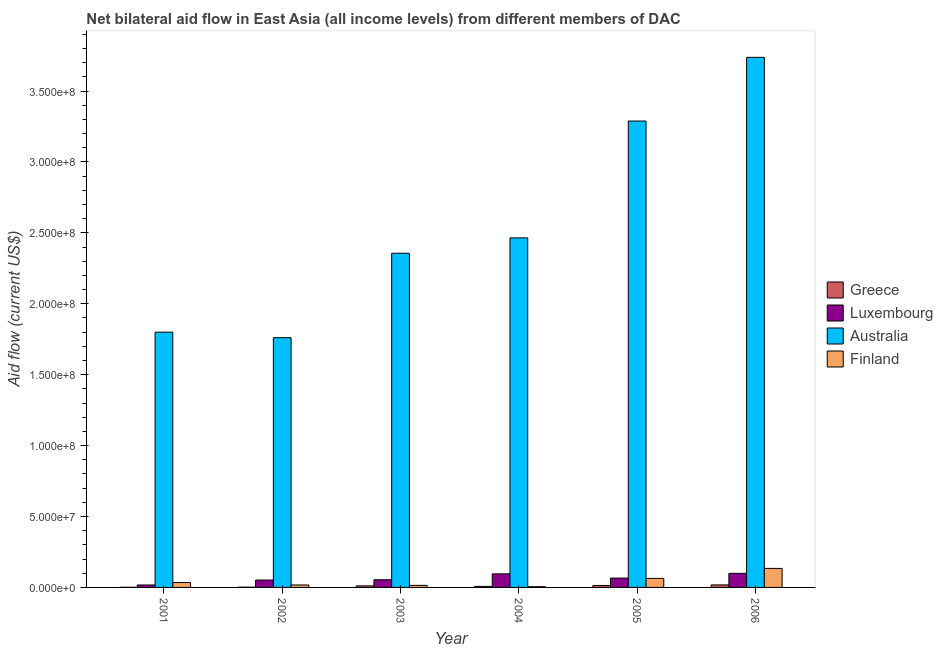How many different coloured bars are there?
Your response must be concise. 4. How many groups of bars are there?
Make the answer very short. 6. Are the number of bars per tick equal to the number of legend labels?
Give a very brief answer. Yes. Are the number of bars on each tick of the X-axis equal?
Keep it short and to the point. Yes. What is the label of the 2nd group of bars from the left?
Your answer should be very brief. 2002. In how many cases, is the number of bars for a given year not equal to the number of legend labels?
Your answer should be very brief. 0. What is the amount of aid given by finland in 2004?
Your answer should be very brief. 5.30e+05. Across all years, what is the maximum amount of aid given by australia?
Offer a terse response. 3.74e+08. Across all years, what is the minimum amount of aid given by greece?
Your answer should be compact. 1.10e+05. What is the total amount of aid given by australia in the graph?
Make the answer very short. 1.54e+09. What is the difference between the amount of aid given by luxembourg in 2001 and that in 2004?
Ensure brevity in your answer.  -7.84e+06. What is the difference between the amount of aid given by greece in 2001 and the amount of aid given by finland in 2002?
Ensure brevity in your answer.  -9.00e+04. What is the average amount of aid given by finland per year?
Give a very brief answer. 4.49e+06. In the year 2005, what is the difference between the amount of aid given by luxembourg and amount of aid given by finland?
Provide a short and direct response. 0. What is the ratio of the amount of aid given by greece in 2001 to that in 2004?
Your answer should be compact. 0.15. Is the amount of aid given by greece in 2004 less than that in 2006?
Your answer should be compact. Yes. Is the difference between the amount of aid given by australia in 2005 and 2006 greater than the difference between the amount of aid given by luxembourg in 2005 and 2006?
Offer a terse response. No. What is the difference between the highest and the lowest amount of aid given by luxembourg?
Offer a terse response. 8.19e+06. Is it the case that in every year, the sum of the amount of aid given by greece and amount of aid given by australia is greater than the sum of amount of aid given by finland and amount of aid given by luxembourg?
Give a very brief answer. No. What does the 4th bar from the left in 2001 represents?
Provide a succinct answer. Finland. Are all the bars in the graph horizontal?
Ensure brevity in your answer.  No. What is the difference between two consecutive major ticks on the Y-axis?
Ensure brevity in your answer.  5.00e+07. Does the graph contain any zero values?
Give a very brief answer. No. Where does the legend appear in the graph?
Your answer should be very brief. Center right. How are the legend labels stacked?
Keep it short and to the point. Vertical. What is the title of the graph?
Provide a short and direct response. Net bilateral aid flow in East Asia (all income levels) from different members of DAC. What is the Aid flow (current US$) in Greece in 2001?
Your answer should be very brief. 1.10e+05. What is the Aid flow (current US$) of Luxembourg in 2001?
Make the answer very short. 1.73e+06. What is the Aid flow (current US$) in Australia in 2001?
Keep it short and to the point. 1.80e+08. What is the Aid flow (current US$) of Finland in 2001?
Offer a very short reply. 3.45e+06. What is the Aid flow (current US$) in Luxembourg in 2002?
Ensure brevity in your answer.  5.21e+06. What is the Aid flow (current US$) of Australia in 2002?
Offer a terse response. 1.76e+08. What is the Aid flow (current US$) in Finland in 2002?
Your response must be concise. 1.73e+06. What is the Aid flow (current US$) of Greece in 2003?
Offer a terse response. 1.09e+06. What is the Aid flow (current US$) of Luxembourg in 2003?
Your answer should be very brief. 5.42e+06. What is the Aid flow (current US$) in Australia in 2003?
Your response must be concise. 2.36e+08. What is the Aid flow (current US$) of Finland in 2003?
Offer a terse response. 1.45e+06. What is the Aid flow (current US$) in Greece in 2004?
Give a very brief answer. 7.20e+05. What is the Aid flow (current US$) in Luxembourg in 2004?
Make the answer very short. 9.57e+06. What is the Aid flow (current US$) of Australia in 2004?
Give a very brief answer. 2.46e+08. What is the Aid flow (current US$) in Finland in 2004?
Provide a succinct answer. 5.30e+05. What is the Aid flow (current US$) in Greece in 2005?
Offer a terse response. 1.38e+06. What is the Aid flow (current US$) of Luxembourg in 2005?
Keep it short and to the point. 6.58e+06. What is the Aid flow (current US$) of Australia in 2005?
Provide a short and direct response. 3.29e+08. What is the Aid flow (current US$) of Finland in 2005?
Ensure brevity in your answer.  6.36e+06. What is the Aid flow (current US$) of Greece in 2006?
Give a very brief answer. 1.77e+06. What is the Aid flow (current US$) in Luxembourg in 2006?
Ensure brevity in your answer.  9.92e+06. What is the Aid flow (current US$) in Australia in 2006?
Keep it short and to the point. 3.74e+08. What is the Aid flow (current US$) in Finland in 2006?
Provide a succinct answer. 1.34e+07. Across all years, what is the maximum Aid flow (current US$) in Greece?
Keep it short and to the point. 1.77e+06. Across all years, what is the maximum Aid flow (current US$) in Luxembourg?
Ensure brevity in your answer.  9.92e+06. Across all years, what is the maximum Aid flow (current US$) in Australia?
Offer a terse response. 3.74e+08. Across all years, what is the maximum Aid flow (current US$) of Finland?
Provide a succinct answer. 1.34e+07. Across all years, what is the minimum Aid flow (current US$) of Greece?
Your answer should be very brief. 1.10e+05. Across all years, what is the minimum Aid flow (current US$) in Luxembourg?
Your response must be concise. 1.73e+06. Across all years, what is the minimum Aid flow (current US$) in Australia?
Give a very brief answer. 1.76e+08. Across all years, what is the minimum Aid flow (current US$) in Finland?
Keep it short and to the point. 5.30e+05. What is the total Aid flow (current US$) in Greece in the graph?
Offer a terse response. 5.27e+06. What is the total Aid flow (current US$) of Luxembourg in the graph?
Make the answer very short. 3.84e+07. What is the total Aid flow (current US$) in Australia in the graph?
Provide a succinct answer. 1.54e+09. What is the total Aid flow (current US$) in Finland in the graph?
Ensure brevity in your answer.  2.69e+07. What is the difference between the Aid flow (current US$) of Greece in 2001 and that in 2002?
Offer a terse response. -9.00e+04. What is the difference between the Aid flow (current US$) in Luxembourg in 2001 and that in 2002?
Keep it short and to the point. -3.48e+06. What is the difference between the Aid flow (current US$) of Australia in 2001 and that in 2002?
Provide a short and direct response. 3.90e+06. What is the difference between the Aid flow (current US$) of Finland in 2001 and that in 2002?
Offer a terse response. 1.72e+06. What is the difference between the Aid flow (current US$) in Greece in 2001 and that in 2003?
Provide a short and direct response. -9.80e+05. What is the difference between the Aid flow (current US$) in Luxembourg in 2001 and that in 2003?
Provide a succinct answer. -3.69e+06. What is the difference between the Aid flow (current US$) in Australia in 2001 and that in 2003?
Your answer should be very brief. -5.56e+07. What is the difference between the Aid flow (current US$) of Greece in 2001 and that in 2004?
Make the answer very short. -6.10e+05. What is the difference between the Aid flow (current US$) in Luxembourg in 2001 and that in 2004?
Your response must be concise. -7.84e+06. What is the difference between the Aid flow (current US$) of Australia in 2001 and that in 2004?
Provide a short and direct response. -6.65e+07. What is the difference between the Aid flow (current US$) of Finland in 2001 and that in 2004?
Give a very brief answer. 2.92e+06. What is the difference between the Aid flow (current US$) of Greece in 2001 and that in 2005?
Your response must be concise. -1.27e+06. What is the difference between the Aid flow (current US$) of Luxembourg in 2001 and that in 2005?
Your answer should be compact. -4.85e+06. What is the difference between the Aid flow (current US$) of Australia in 2001 and that in 2005?
Offer a terse response. -1.49e+08. What is the difference between the Aid flow (current US$) of Finland in 2001 and that in 2005?
Your answer should be compact. -2.91e+06. What is the difference between the Aid flow (current US$) of Greece in 2001 and that in 2006?
Keep it short and to the point. -1.66e+06. What is the difference between the Aid flow (current US$) in Luxembourg in 2001 and that in 2006?
Your answer should be very brief. -8.19e+06. What is the difference between the Aid flow (current US$) of Australia in 2001 and that in 2006?
Your answer should be very brief. -1.94e+08. What is the difference between the Aid flow (current US$) of Finland in 2001 and that in 2006?
Your answer should be very brief. -9.95e+06. What is the difference between the Aid flow (current US$) of Greece in 2002 and that in 2003?
Your answer should be compact. -8.90e+05. What is the difference between the Aid flow (current US$) of Luxembourg in 2002 and that in 2003?
Make the answer very short. -2.10e+05. What is the difference between the Aid flow (current US$) of Australia in 2002 and that in 2003?
Your answer should be very brief. -5.95e+07. What is the difference between the Aid flow (current US$) in Greece in 2002 and that in 2004?
Offer a terse response. -5.20e+05. What is the difference between the Aid flow (current US$) in Luxembourg in 2002 and that in 2004?
Ensure brevity in your answer.  -4.36e+06. What is the difference between the Aid flow (current US$) in Australia in 2002 and that in 2004?
Make the answer very short. -7.04e+07. What is the difference between the Aid flow (current US$) of Finland in 2002 and that in 2004?
Your response must be concise. 1.20e+06. What is the difference between the Aid flow (current US$) of Greece in 2002 and that in 2005?
Keep it short and to the point. -1.18e+06. What is the difference between the Aid flow (current US$) in Luxembourg in 2002 and that in 2005?
Your answer should be compact. -1.37e+06. What is the difference between the Aid flow (current US$) in Australia in 2002 and that in 2005?
Keep it short and to the point. -1.53e+08. What is the difference between the Aid flow (current US$) in Finland in 2002 and that in 2005?
Offer a very short reply. -4.63e+06. What is the difference between the Aid flow (current US$) of Greece in 2002 and that in 2006?
Provide a succinct answer. -1.57e+06. What is the difference between the Aid flow (current US$) of Luxembourg in 2002 and that in 2006?
Your answer should be compact. -4.71e+06. What is the difference between the Aid flow (current US$) of Australia in 2002 and that in 2006?
Offer a terse response. -1.98e+08. What is the difference between the Aid flow (current US$) in Finland in 2002 and that in 2006?
Provide a short and direct response. -1.17e+07. What is the difference between the Aid flow (current US$) of Greece in 2003 and that in 2004?
Offer a very short reply. 3.70e+05. What is the difference between the Aid flow (current US$) of Luxembourg in 2003 and that in 2004?
Offer a very short reply. -4.15e+06. What is the difference between the Aid flow (current US$) of Australia in 2003 and that in 2004?
Your answer should be compact. -1.08e+07. What is the difference between the Aid flow (current US$) in Finland in 2003 and that in 2004?
Your answer should be very brief. 9.20e+05. What is the difference between the Aid flow (current US$) of Greece in 2003 and that in 2005?
Keep it short and to the point. -2.90e+05. What is the difference between the Aid flow (current US$) in Luxembourg in 2003 and that in 2005?
Offer a terse response. -1.16e+06. What is the difference between the Aid flow (current US$) in Australia in 2003 and that in 2005?
Your answer should be very brief. -9.32e+07. What is the difference between the Aid flow (current US$) of Finland in 2003 and that in 2005?
Your answer should be very brief. -4.91e+06. What is the difference between the Aid flow (current US$) of Greece in 2003 and that in 2006?
Provide a short and direct response. -6.80e+05. What is the difference between the Aid flow (current US$) in Luxembourg in 2003 and that in 2006?
Provide a succinct answer. -4.50e+06. What is the difference between the Aid flow (current US$) of Australia in 2003 and that in 2006?
Offer a terse response. -1.38e+08. What is the difference between the Aid flow (current US$) in Finland in 2003 and that in 2006?
Your answer should be compact. -1.20e+07. What is the difference between the Aid flow (current US$) in Greece in 2004 and that in 2005?
Provide a short and direct response. -6.60e+05. What is the difference between the Aid flow (current US$) in Luxembourg in 2004 and that in 2005?
Your answer should be very brief. 2.99e+06. What is the difference between the Aid flow (current US$) in Australia in 2004 and that in 2005?
Keep it short and to the point. -8.24e+07. What is the difference between the Aid flow (current US$) in Finland in 2004 and that in 2005?
Make the answer very short. -5.83e+06. What is the difference between the Aid flow (current US$) of Greece in 2004 and that in 2006?
Keep it short and to the point. -1.05e+06. What is the difference between the Aid flow (current US$) of Luxembourg in 2004 and that in 2006?
Your answer should be very brief. -3.50e+05. What is the difference between the Aid flow (current US$) of Australia in 2004 and that in 2006?
Your response must be concise. -1.27e+08. What is the difference between the Aid flow (current US$) of Finland in 2004 and that in 2006?
Offer a terse response. -1.29e+07. What is the difference between the Aid flow (current US$) in Greece in 2005 and that in 2006?
Your answer should be very brief. -3.90e+05. What is the difference between the Aid flow (current US$) of Luxembourg in 2005 and that in 2006?
Give a very brief answer. -3.34e+06. What is the difference between the Aid flow (current US$) in Australia in 2005 and that in 2006?
Keep it short and to the point. -4.49e+07. What is the difference between the Aid flow (current US$) of Finland in 2005 and that in 2006?
Your answer should be compact. -7.04e+06. What is the difference between the Aid flow (current US$) in Greece in 2001 and the Aid flow (current US$) in Luxembourg in 2002?
Keep it short and to the point. -5.10e+06. What is the difference between the Aid flow (current US$) of Greece in 2001 and the Aid flow (current US$) of Australia in 2002?
Your response must be concise. -1.76e+08. What is the difference between the Aid flow (current US$) in Greece in 2001 and the Aid flow (current US$) in Finland in 2002?
Your answer should be very brief. -1.62e+06. What is the difference between the Aid flow (current US$) in Luxembourg in 2001 and the Aid flow (current US$) in Australia in 2002?
Give a very brief answer. -1.74e+08. What is the difference between the Aid flow (current US$) of Australia in 2001 and the Aid flow (current US$) of Finland in 2002?
Offer a very short reply. 1.78e+08. What is the difference between the Aid flow (current US$) in Greece in 2001 and the Aid flow (current US$) in Luxembourg in 2003?
Your answer should be compact. -5.31e+06. What is the difference between the Aid flow (current US$) in Greece in 2001 and the Aid flow (current US$) in Australia in 2003?
Provide a short and direct response. -2.36e+08. What is the difference between the Aid flow (current US$) in Greece in 2001 and the Aid flow (current US$) in Finland in 2003?
Offer a terse response. -1.34e+06. What is the difference between the Aid flow (current US$) of Luxembourg in 2001 and the Aid flow (current US$) of Australia in 2003?
Ensure brevity in your answer.  -2.34e+08. What is the difference between the Aid flow (current US$) in Australia in 2001 and the Aid flow (current US$) in Finland in 2003?
Keep it short and to the point. 1.79e+08. What is the difference between the Aid flow (current US$) of Greece in 2001 and the Aid flow (current US$) of Luxembourg in 2004?
Ensure brevity in your answer.  -9.46e+06. What is the difference between the Aid flow (current US$) in Greece in 2001 and the Aid flow (current US$) in Australia in 2004?
Ensure brevity in your answer.  -2.46e+08. What is the difference between the Aid flow (current US$) of Greece in 2001 and the Aid flow (current US$) of Finland in 2004?
Your answer should be very brief. -4.20e+05. What is the difference between the Aid flow (current US$) of Luxembourg in 2001 and the Aid flow (current US$) of Australia in 2004?
Your answer should be compact. -2.45e+08. What is the difference between the Aid flow (current US$) in Luxembourg in 2001 and the Aid flow (current US$) in Finland in 2004?
Your response must be concise. 1.20e+06. What is the difference between the Aid flow (current US$) of Australia in 2001 and the Aid flow (current US$) of Finland in 2004?
Ensure brevity in your answer.  1.79e+08. What is the difference between the Aid flow (current US$) in Greece in 2001 and the Aid flow (current US$) in Luxembourg in 2005?
Your response must be concise. -6.47e+06. What is the difference between the Aid flow (current US$) in Greece in 2001 and the Aid flow (current US$) in Australia in 2005?
Give a very brief answer. -3.29e+08. What is the difference between the Aid flow (current US$) in Greece in 2001 and the Aid flow (current US$) in Finland in 2005?
Offer a very short reply. -6.25e+06. What is the difference between the Aid flow (current US$) of Luxembourg in 2001 and the Aid flow (current US$) of Australia in 2005?
Offer a very short reply. -3.27e+08. What is the difference between the Aid flow (current US$) of Luxembourg in 2001 and the Aid flow (current US$) of Finland in 2005?
Give a very brief answer. -4.63e+06. What is the difference between the Aid flow (current US$) of Australia in 2001 and the Aid flow (current US$) of Finland in 2005?
Provide a short and direct response. 1.74e+08. What is the difference between the Aid flow (current US$) of Greece in 2001 and the Aid flow (current US$) of Luxembourg in 2006?
Make the answer very short. -9.81e+06. What is the difference between the Aid flow (current US$) in Greece in 2001 and the Aid flow (current US$) in Australia in 2006?
Your answer should be very brief. -3.74e+08. What is the difference between the Aid flow (current US$) of Greece in 2001 and the Aid flow (current US$) of Finland in 2006?
Keep it short and to the point. -1.33e+07. What is the difference between the Aid flow (current US$) in Luxembourg in 2001 and the Aid flow (current US$) in Australia in 2006?
Offer a very short reply. -3.72e+08. What is the difference between the Aid flow (current US$) in Luxembourg in 2001 and the Aid flow (current US$) in Finland in 2006?
Give a very brief answer. -1.17e+07. What is the difference between the Aid flow (current US$) of Australia in 2001 and the Aid flow (current US$) of Finland in 2006?
Your answer should be compact. 1.67e+08. What is the difference between the Aid flow (current US$) in Greece in 2002 and the Aid flow (current US$) in Luxembourg in 2003?
Keep it short and to the point. -5.22e+06. What is the difference between the Aid flow (current US$) in Greece in 2002 and the Aid flow (current US$) in Australia in 2003?
Your answer should be very brief. -2.35e+08. What is the difference between the Aid flow (current US$) of Greece in 2002 and the Aid flow (current US$) of Finland in 2003?
Your answer should be very brief. -1.25e+06. What is the difference between the Aid flow (current US$) of Luxembourg in 2002 and the Aid flow (current US$) of Australia in 2003?
Provide a short and direct response. -2.30e+08. What is the difference between the Aid flow (current US$) in Luxembourg in 2002 and the Aid flow (current US$) in Finland in 2003?
Offer a terse response. 3.76e+06. What is the difference between the Aid flow (current US$) of Australia in 2002 and the Aid flow (current US$) of Finland in 2003?
Your answer should be compact. 1.75e+08. What is the difference between the Aid flow (current US$) in Greece in 2002 and the Aid flow (current US$) in Luxembourg in 2004?
Keep it short and to the point. -9.37e+06. What is the difference between the Aid flow (current US$) of Greece in 2002 and the Aid flow (current US$) of Australia in 2004?
Your answer should be very brief. -2.46e+08. What is the difference between the Aid flow (current US$) of Greece in 2002 and the Aid flow (current US$) of Finland in 2004?
Keep it short and to the point. -3.30e+05. What is the difference between the Aid flow (current US$) in Luxembourg in 2002 and the Aid flow (current US$) in Australia in 2004?
Make the answer very short. -2.41e+08. What is the difference between the Aid flow (current US$) of Luxembourg in 2002 and the Aid flow (current US$) of Finland in 2004?
Your response must be concise. 4.68e+06. What is the difference between the Aid flow (current US$) in Australia in 2002 and the Aid flow (current US$) in Finland in 2004?
Your response must be concise. 1.76e+08. What is the difference between the Aid flow (current US$) in Greece in 2002 and the Aid flow (current US$) in Luxembourg in 2005?
Make the answer very short. -6.38e+06. What is the difference between the Aid flow (current US$) of Greece in 2002 and the Aid flow (current US$) of Australia in 2005?
Your response must be concise. -3.29e+08. What is the difference between the Aid flow (current US$) of Greece in 2002 and the Aid flow (current US$) of Finland in 2005?
Provide a succinct answer. -6.16e+06. What is the difference between the Aid flow (current US$) in Luxembourg in 2002 and the Aid flow (current US$) in Australia in 2005?
Keep it short and to the point. -3.24e+08. What is the difference between the Aid flow (current US$) of Luxembourg in 2002 and the Aid flow (current US$) of Finland in 2005?
Your answer should be compact. -1.15e+06. What is the difference between the Aid flow (current US$) in Australia in 2002 and the Aid flow (current US$) in Finland in 2005?
Provide a succinct answer. 1.70e+08. What is the difference between the Aid flow (current US$) in Greece in 2002 and the Aid flow (current US$) in Luxembourg in 2006?
Provide a succinct answer. -9.72e+06. What is the difference between the Aid flow (current US$) in Greece in 2002 and the Aid flow (current US$) in Australia in 2006?
Provide a succinct answer. -3.74e+08. What is the difference between the Aid flow (current US$) of Greece in 2002 and the Aid flow (current US$) of Finland in 2006?
Provide a short and direct response. -1.32e+07. What is the difference between the Aid flow (current US$) of Luxembourg in 2002 and the Aid flow (current US$) of Australia in 2006?
Provide a succinct answer. -3.69e+08. What is the difference between the Aid flow (current US$) in Luxembourg in 2002 and the Aid flow (current US$) in Finland in 2006?
Provide a short and direct response. -8.19e+06. What is the difference between the Aid flow (current US$) of Australia in 2002 and the Aid flow (current US$) of Finland in 2006?
Make the answer very short. 1.63e+08. What is the difference between the Aid flow (current US$) in Greece in 2003 and the Aid flow (current US$) in Luxembourg in 2004?
Give a very brief answer. -8.48e+06. What is the difference between the Aid flow (current US$) of Greece in 2003 and the Aid flow (current US$) of Australia in 2004?
Provide a succinct answer. -2.45e+08. What is the difference between the Aid flow (current US$) of Greece in 2003 and the Aid flow (current US$) of Finland in 2004?
Make the answer very short. 5.60e+05. What is the difference between the Aid flow (current US$) of Luxembourg in 2003 and the Aid flow (current US$) of Australia in 2004?
Provide a short and direct response. -2.41e+08. What is the difference between the Aid flow (current US$) of Luxembourg in 2003 and the Aid flow (current US$) of Finland in 2004?
Provide a succinct answer. 4.89e+06. What is the difference between the Aid flow (current US$) of Australia in 2003 and the Aid flow (current US$) of Finland in 2004?
Provide a succinct answer. 2.35e+08. What is the difference between the Aid flow (current US$) in Greece in 2003 and the Aid flow (current US$) in Luxembourg in 2005?
Give a very brief answer. -5.49e+06. What is the difference between the Aid flow (current US$) in Greece in 2003 and the Aid flow (current US$) in Australia in 2005?
Offer a terse response. -3.28e+08. What is the difference between the Aid flow (current US$) in Greece in 2003 and the Aid flow (current US$) in Finland in 2005?
Provide a short and direct response. -5.27e+06. What is the difference between the Aid flow (current US$) of Luxembourg in 2003 and the Aid flow (current US$) of Australia in 2005?
Your response must be concise. -3.23e+08. What is the difference between the Aid flow (current US$) of Luxembourg in 2003 and the Aid flow (current US$) of Finland in 2005?
Your response must be concise. -9.40e+05. What is the difference between the Aid flow (current US$) of Australia in 2003 and the Aid flow (current US$) of Finland in 2005?
Provide a short and direct response. 2.29e+08. What is the difference between the Aid flow (current US$) of Greece in 2003 and the Aid flow (current US$) of Luxembourg in 2006?
Give a very brief answer. -8.83e+06. What is the difference between the Aid flow (current US$) in Greece in 2003 and the Aid flow (current US$) in Australia in 2006?
Keep it short and to the point. -3.73e+08. What is the difference between the Aid flow (current US$) in Greece in 2003 and the Aid flow (current US$) in Finland in 2006?
Provide a short and direct response. -1.23e+07. What is the difference between the Aid flow (current US$) of Luxembourg in 2003 and the Aid flow (current US$) of Australia in 2006?
Ensure brevity in your answer.  -3.68e+08. What is the difference between the Aid flow (current US$) of Luxembourg in 2003 and the Aid flow (current US$) of Finland in 2006?
Offer a terse response. -7.98e+06. What is the difference between the Aid flow (current US$) of Australia in 2003 and the Aid flow (current US$) of Finland in 2006?
Ensure brevity in your answer.  2.22e+08. What is the difference between the Aid flow (current US$) in Greece in 2004 and the Aid flow (current US$) in Luxembourg in 2005?
Ensure brevity in your answer.  -5.86e+06. What is the difference between the Aid flow (current US$) of Greece in 2004 and the Aid flow (current US$) of Australia in 2005?
Provide a short and direct response. -3.28e+08. What is the difference between the Aid flow (current US$) in Greece in 2004 and the Aid flow (current US$) in Finland in 2005?
Your answer should be compact. -5.64e+06. What is the difference between the Aid flow (current US$) in Luxembourg in 2004 and the Aid flow (current US$) in Australia in 2005?
Offer a very short reply. -3.19e+08. What is the difference between the Aid flow (current US$) in Luxembourg in 2004 and the Aid flow (current US$) in Finland in 2005?
Your answer should be compact. 3.21e+06. What is the difference between the Aid flow (current US$) in Australia in 2004 and the Aid flow (current US$) in Finland in 2005?
Your answer should be compact. 2.40e+08. What is the difference between the Aid flow (current US$) in Greece in 2004 and the Aid flow (current US$) in Luxembourg in 2006?
Offer a terse response. -9.20e+06. What is the difference between the Aid flow (current US$) in Greece in 2004 and the Aid flow (current US$) in Australia in 2006?
Your response must be concise. -3.73e+08. What is the difference between the Aid flow (current US$) in Greece in 2004 and the Aid flow (current US$) in Finland in 2006?
Make the answer very short. -1.27e+07. What is the difference between the Aid flow (current US$) in Luxembourg in 2004 and the Aid flow (current US$) in Australia in 2006?
Provide a short and direct response. -3.64e+08. What is the difference between the Aid flow (current US$) in Luxembourg in 2004 and the Aid flow (current US$) in Finland in 2006?
Offer a very short reply. -3.83e+06. What is the difference between the Aid flow (current US$) of Australia in 2004 and the Aid flow (current US$) of Finland in 2006?
Your answer should be compact. 2.33e+08. What is the difference between the Aid flow (current US$) in Greece in 2005 and the Aid flow (current US$) in Luxembourg in 2006?
Provide a succinct answer. -8.54e+06. What is the difference between the Aid flow (current US$) in Greece in 2005 and the Aid flow (current US$) in Australia in 2006?
Offer a terse response. -3.72e+08. What is the difference between the Aid flow (current US$) in Greece in 2005 and the Aid flow (current US$) in Finland in 2006?
Provide a succinct answer. -1.20e+07. What is the difference between the Aid flow (current US$) of Luxembourg in 2005 and the Aid flow (current US$) of Australia in 2006?
Your response must be concise. -3.67e+08. What is the difference between the Aid flow (current US$) in Luxembourg in 2005 and the Aid flow (current US$) in Finland in 2006?
Keep it short and to the point. -6.82e+06. What is the difference between the Aid flow (current US$) in Australia in 2005 and the Aid flow (current US$) in Finland in 2006?
Give a very brief answer. 3.15e+08. What is the average Aid flow (current US$) in Greece per year?
Your answer should be very brief. 8.78e+05. What is the average Aid flow (current US$) of Luxembourg per year?
Offer a very short reply. 6.40e+06. What is the average Aid flow (current US$) of Australia per year?
Ensure brevity in your answer.  2.57e+08. What is the average Aid flow (current US$) of Finland per year?
Make the answer very short. 4.49e+06. In the year 2001, what is the difference between the Aid flow (current US$) of Greece and Aid flow (current US$) of Luxembourg?
Offer a very short reply. -1.62e+06. In the year 2001, what is the difference between the Aid flow (current US$) of Greece and Aid flow (current US$) of Australia?
Keep it short and to the point. -1.80e+08. In the year 2001, what is the difference between the Aid flow (current US$) of Greece and Aid flow (current US$) of Finland?
Offer a very short reply. -3.34e+06. In the year 2001, what is the difference between the Aid flow (current US$) of Luxembourg and Aid flow (current US$) of Australia?
Your answer should be very brief. -1.78e+08. In the year 2001, what is the difference between the Aid flow (current US$) of Luxembourg and Aid flow (current US$) of Finland?
Your response must be concise. -1.72e+06. In the year 2001, what is the difference between the Aid flow (current US$) of Australia and Aid flow (current US$) of Finland?
Give a very brief answer. 1.77e+08. In the year 2002, what is the difference between the Aid flow (current US$) of Greece and Aid flow (current US$) of Luxembourg?
Offer a terse response. -5.01e+06. In the year 2002, what is the difference between the Aid flow (current US$) of Greece and Aid flow (current US$) of Australia?
Your answer should be very brief. -1.76e+08. In the year 2002, what is the difference between the Aid flow (current US$) of Greece and Aid flow (current US$) of Finland?
Your answer should be very brief. -1.53e+06. In the year 2002, what is the difference between the Aid flow (current US$) in Luxembourg and Aid flow (current US$) in Australia?
Your answer should be compact. -1.71e+08. In the year 2002, what is the difference between the Aid flow (current US$) of Luxembourg and Aid flow (current US$) of Finland?
Your response must be concise. 3.48e+06. In the year 2002, what is the difference between the Aid flow (current US$) of Australia and Aid flow (current US$) of Finland?
Give a very brief answer. 1.74e+08. In the year 2003, what is the difference between the Aid flow (current US$) in Greece and Aid flow (current US$) in Luxembourg?
Your answer should be very brief. -4.33e+06. In the year 2003, what is the difference between the Aid flow (current US$) in Greece and Aid flow (current US$) in Australia?
Offer a terse response. -2.35e+08. In the year 2003, what is the difference between the Aid flow (current US$) in Greece and Aid flow (current US$) in Finland?
Ensure brevity in your answer.  -3.60e+05. In the year 2003, what is the difference between the Aid flow (current US$) of Luxembourg and Aid flow (current US$) of Australia?
Your answer should be compact. -2.30e+08. In the year 2003, what is the difference between the Aid flow (current US$) of Luxembourg and Aid flow (current US$) of Finland?
Your response must be concise. 3.97e+06. In the year 2003, what is the difference between the Aid flow (current US$) of Australia and Aid flow (current US$) of Finland?
Offer a very short reply. 2.34e+08. In the year 2004, what is the difference between the Aid flow (current US$) in Greece and Aid flow (current US$) in Luxembourg?
Your answer should be very brief. -8.85e+06. In the year 2004, what is the difference between the Aid flow (current US$) in Greece and Aid flow (current US$) in Australia?
Give a very brief answer. -2.46e+08. In the year 2004, what is the difference between the Aid flow (current US$) of Greece and Aid flow (current US$) of Finland?
Offer a terse response. 1.90e+05. In the year 2004, what is the difference between the Aid flow (current US$) of Luxembourg and Aid flow (current US$) of Australia?
Offer a terse response. -2.37e+08. In the year 2004, what is the difference between the Aid flow (current US$) in Luxembourg and Aid flow (current US$) in Finland?
Keep it short and to the point. 9.04e+06. In the year 2004, what is the difference between the Aid flow (current US$) of Australia and Aid flow (current US$) of Finland?
Provide a short and direct response. 2.46e+08. In the year 2005, what is the difference between the Aid flow (current US$) of Greece and Aid flow (current US$) of Luxembourg?
Your answer should be compact. -5.20e+06. In the year 2005, what is the difference between the Aid flow (current US$) of Greece and Aid flow (current US$) of Australia?
Offer a very short reply. -3.27e+08. In the year 2005, what is the difference between the Aid flow (current US$) in Greece and Aid flow (current US$) in Finland?
Provide a succinct answer. -4.98e+06. In the year 2005, what is the difference between the Aid flow (current US$) in Luxembourg and Aid flow (current US$) in Australia?
Offer a very short reply. -3.22e+08. In the year 2005, what is the difference between the Aid flow (current US$) in Luxembourg and Aid flow (current US$) in Finland?
Your answer should be compact. 2.20e+05. In the year 2005, what is the difference between the Aid flow (current US$) of Australia and Aid flow (current US$) of Finland?
Offer a very short reply. 3.22e+08. In the year 2006, what is the difference between the Aid flow (current US$) in Greece and Aid flow (current US$) in Luxembourg?
Offer a very short reply. -8.15e+06. In the year 2006, what is the difference between the Aid flow (current US$) of Greece and Aid flow (current US$) of Australia?
Your response must be concise. -3.72e+08. In the year 2006, what is the difference between the Aid flow (current US$) of Greece and Aid flow (current US$) of Finland?
Provide a short and direct response. -1.16e+07. In the year 2006, what is the difference between the Aid flow (current US$) of Luxembourg and Aid flow (current US$) of Australia?
Your answer should be very brief. -3.64e+08. In the year 2006, what is the difference between the Aid flow (current US$) of Luxembourg and Aid flow (current US$) of Finland?
Your answer should be compact. -3.48e+06. In the year 2006, what is the difference between the Aid flow (current US$) of Australia and Aid flow (current US$) of Finland?
Provide a succinct answer. 3.60e+08. What is the ratio of the Aid flow (current US$) in Greece in 2001 to that in 2002?
Provide a short and direct response. 0.55. What is the ratio of the Aid flow (current US$) of Luxembourg in 2001 to that in 2002?
Make the answer very short. 0.33. What is the ratio of the Aid flow (current US$) of Australia in 2001 to that in 2002?
Provide a short and direct response. 1.02. What is the ratio of the Aid flow (current US$) in Finland in 2001 to that in 2002?
Keep it short and to the point. 1.99. What is the ratio of the Aid flow (current US$) in Greece in 2001 to that in 2003?
Provide a short and direct response. 0.1. What is the ratio of the Aid flow (current US$) in Luxembourg in 2001 to that in 2003?
Ensure brevity in your answer.  0.32. What is the ratio of the Aid flow (current US$) of Australia in 2001 to that in 2003?
Give a very brief answer. 0.76. What is the ratio of the Aid flow (current US$) in Finland in 2001 to that in 2003?
Ensure brevity in your answer.  2.38. What is the ratio of the Aid flow (current US$) in Greece in 2001 to that in 2004?
Provide a short and direct response. 0.15. What is the ratio of the Aid flow (current US$) in Luxembourg in 2001 to that in 2004?
Keep it short and to the point. 0.18. What is the ratio of the Aid flow (current US$) in Australia in 2001 to that in 2004?
Offer a very short reply. 0.73. What is the ratio of the Aid flow (current US$) of Finland in 2001 to that in 2004?
Make the answer very short. 6.51. What is the ratio of the Aid flow (current US$) in Greece in 2001 to that in 2005?
Your answer should be compact. 0.08. What is the ratio of the Aid flow (current US$) of Luxembourg in 2001 to that in 2005?
Provide a succinct answer. 0.26. What is the ratio of the Aid flow (current US$) of Australia in 2001 to that in 2005?
Provide a succinct answer. 0.55. What is the ratio of the Aid flow (current US$) of Finland in 2001 to that in 2005?
Give a very brief answer. 0.54. What is the ratio of the Aid flow (current US$) in Greece in 2001 to that in 2006?
Offer a terse response. 0.06. What is the ratio of the Aid flow (current US$) of Luxembourg in 2001 to that in 2006?
Your answer should be compact. 0.17. What is the ratio of the Aid flow (current US$) in Australia in 2001 to that in 2006?
Keep it short and to the point. 0.48. What is the ratio of the Aid flow (current US$) in Finland in 2001 to that in 2006?
Your answer should be very brief. 0.26. What is the ratio of the Aid flow (current US$) of Greece in 2002 to that in 2003?
Keep it short and to the point. 0.18. What is the ratio of the Aid flow (current US$) of Luxembourg in 2002 to that in 2003?
Your answer should be compact. 0.96. What is the ratio of the Aid flow (current US$) in Australia in 2002 to that in 2003?
Your response must be concise. 0.75. What is the ratio of the Aid flow (current US$) in Finland in 2002 to that in 2003?
Ensure brevity in your answer.  1.19. What is the ratio of the Aid flow (current US$) in Greece in 2002 to that in 2004?
Keep it short and to the point. 0.28. What is the ratio of the Aid flow (current US$) of Luxembourg in 2002 to that in 2004?
Your answer should be very brief. 0.54. What is the ratio of the Aid flow (current US$) of Australia in 2002 to that in 2004?
Offer a very short reply. 0.71. What is the ratio of the Aid flow (current US$) in Finland in 2002 to that in 2004?
Provide a short and direct response. 3.26. What is the ratio of the Aid flow (current US$) of Greece in 2002 to that in 2005?
Provide a short and direct response. 0.14. What is the ratio of the Aid flow (current US$) in Luxembourg in 2002 to that in 2005?
Ensure brevity in your answer.  0.79. What is the ratio of the Aid flow (current US$) of Australia in 2002 to that in 2005?
Make the answer very short. 0.54. What is the ratio of the Aid flow (current US$) in Finland in 2002 to that in 2005?
Ensure brevity in your answer.  0.27. What is the ratio of the Aid flow (current US$) in Greece in 2002 to that in 2006?
Make the answer very short. 0.11. What is the ratio of the Aid flow (current US$) of Luxembourg in 2002 to that in 2006?
Your answer should be very brief. 0.53. What is the ratio of the Aid flow (current US$) of Australia in 2002 to that in 2006?
Offer a terse response. 0.47. What is the ratio of the Aid flow (current US$) of Finland in 2002 to that in 2006?
Offer a terse response. 0.13. What is the ratio of the Aid flow (current US$) in Greece in 2003 to that in 2004?
Offer a very short reply. 1.51. What is the ratio of the Aid flow (current US$) of Luxembourg in 2003 to that in 2004?
Offer a terse response. 0.57. What is the ratio of the Aid flow (current US$) in Australia in 2003 to that in 2004?
Ensure brevity in your answer.  0.96. What is the ratio of the Aid flow (current US$) in Finland in 2003 to that in 2004?
Your answer should be compact. 2.74. What is the ratio of the Aid flow (current US$) in Greece in 2003 to that in 2005?
Ensure brevity in your answer.  0.79. What is the ratio of the Aid flow (current US$) in Luxembourg in 2003 to that in 2005?
Provide a succinct answer. 0.82. What is the ratio of the Aid flow (current US$) in Australia in 2003 to that in 2005?
Provide a succinct answer. 0.72. What is the ratio of the Aid flow (current US$) of Finland in 2003 to that in 2005?
Offer a very short reply. 0.23. What is the ratio of the Aid flow (current US$) of Greece in 2003 to that in 2006?
Your answer should be very brief. 0.62. What is the ratio of the Aid flow (current US$) of Luxembourg in 2003 to that in 2006?
Your response must be concise. 0.55. What is the ratio of the Aid flow (current US$) in Australia in 2003 to that in 2006?
Offer a very short reply. 0.63. What is the ratio of the Aid flow (current US$) of Finland in 2003 to that in 2006?
Offer a terse response. 0.11. What is the ratio of the Aid flow (current US$) in Greece in 2004 to that in 2005?
Provide a succinct answer. 0.52. What is the ratio of the Aid flow (current US$) in Luxembourg in 2004 to that in 2005?
Keep it short and to the point. 1.45. What is the ratio of the Aid flow (current US$) in Australia in 2004 to that in 2005?
Give a very brief answer. 0.75. What is the ratio of the Aid flow (current US$) of Finland in 2004 to that in 2005?
Provide a succinct answer. 0.08. What is the ratio of the Aid flow (current US$) in Greece in 2004 to that in 2006?
Offer a terse response. 0.41. What is the ratio of the Aid flow (current US$) of Luxembourg in 2004 to that in 2006?
Offer a terse response. 0.96. What is the ratio of the Aid flow (current US$) of Australia in 2004 to that in 2006?
Provide a short and direct response. 0.66. What is the ratio of the Aid flow (current US$) of Finland in 2004 to that in 2006?
Provide a short and direct response. 0.04. What is the ratio of the Aid flow (current US$) in Greece in 2005 to that in 2006?
Make the answer very short. 0.78. What is the ratio of the Aid flow (current US$) in Luxembourg in 2005 to that in 2006?
Provide a short and direct response. 0.66. What is the ratio of the Aid flow (current US$) of Australia in 2005 to that in 2006?
Ensure brevity in your answer.  0.88. What is the ratio of the Aid flow (current US$) of Finland in 2005 to that in 2006?
Your response must be concise. 0.47. What is the difference between the highest and the second highest Aid flow (current US$) in Greece?
Offer a terse response. 3.90e+05. What is the difference between the highest and the second highest Aid flow (current US$) of Luxembourg?
Provide a succinct answer. 3.50e+05. What is the difference between the highest and the second highest Aid flow (current US$) of Australia?
Provide a short and direct response. 4.49e+07. What is the difference between the highest and the second highest Aid flow (current US$) of Finland?
Provide a succinct answer. 7.04e+06. What is the difference between the highest and the lowest Aid flow (current US$) of Greece?
Your response must be concise. 1.66e+06. What is the difference between the highest and the lowest Aid flow (current US$) of Luxembourg?
Your response must be concise. 8.19e+06. What is the difference between the highest and the lowest Aid flow (current US$) in Australia?
Provide a short and direct response. 1.98e+08. What is the difference between the highest and the lowest Aid flow (current US$) of Finland?
Offer a very short reply. 1.29e+07. 